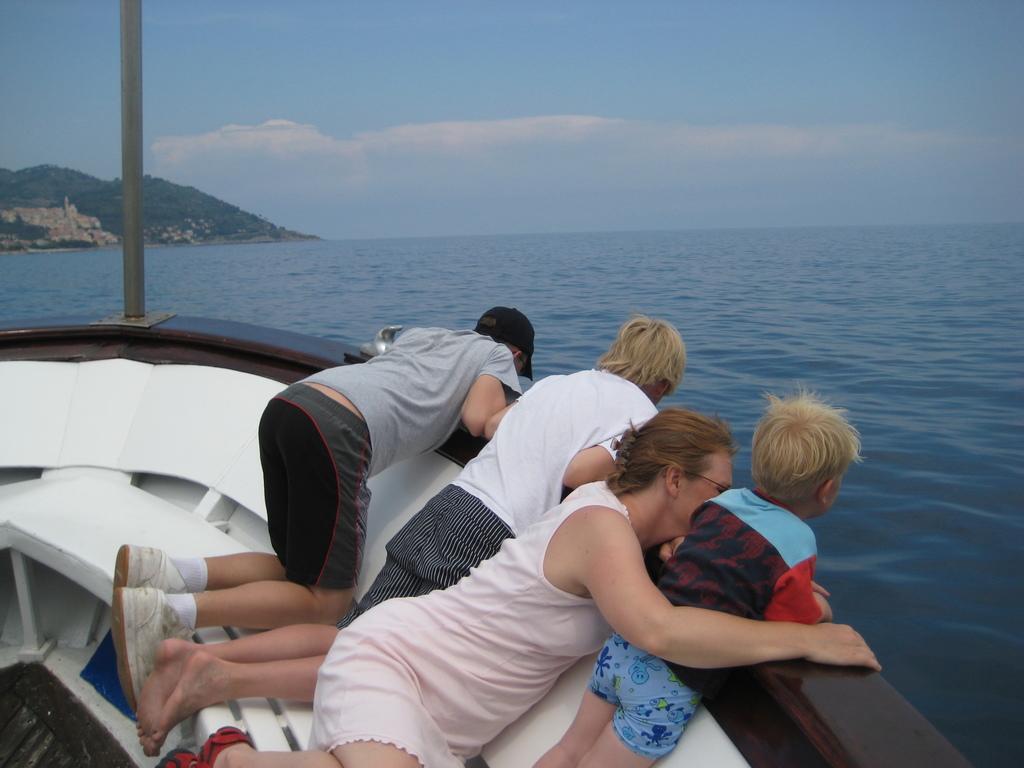Can you describe this image briefly? In this image there are people in the boat. Left side there is a person wearing the cap. The boat is sailing on the surface of the water. Left side there are hills. Top of the image there is sky with some clouds. 